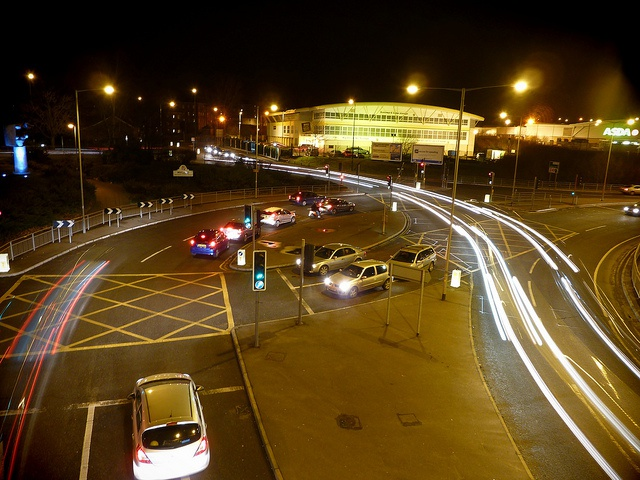Describe the objects in this image and their specific colors. I can see car in black, white, and olive tones, car in black, olive, and white tones, car in black, olive, and maroon tones, car in black, olive, and maroon tones, and car in black, maroon, brown, and purple tones in this image. 